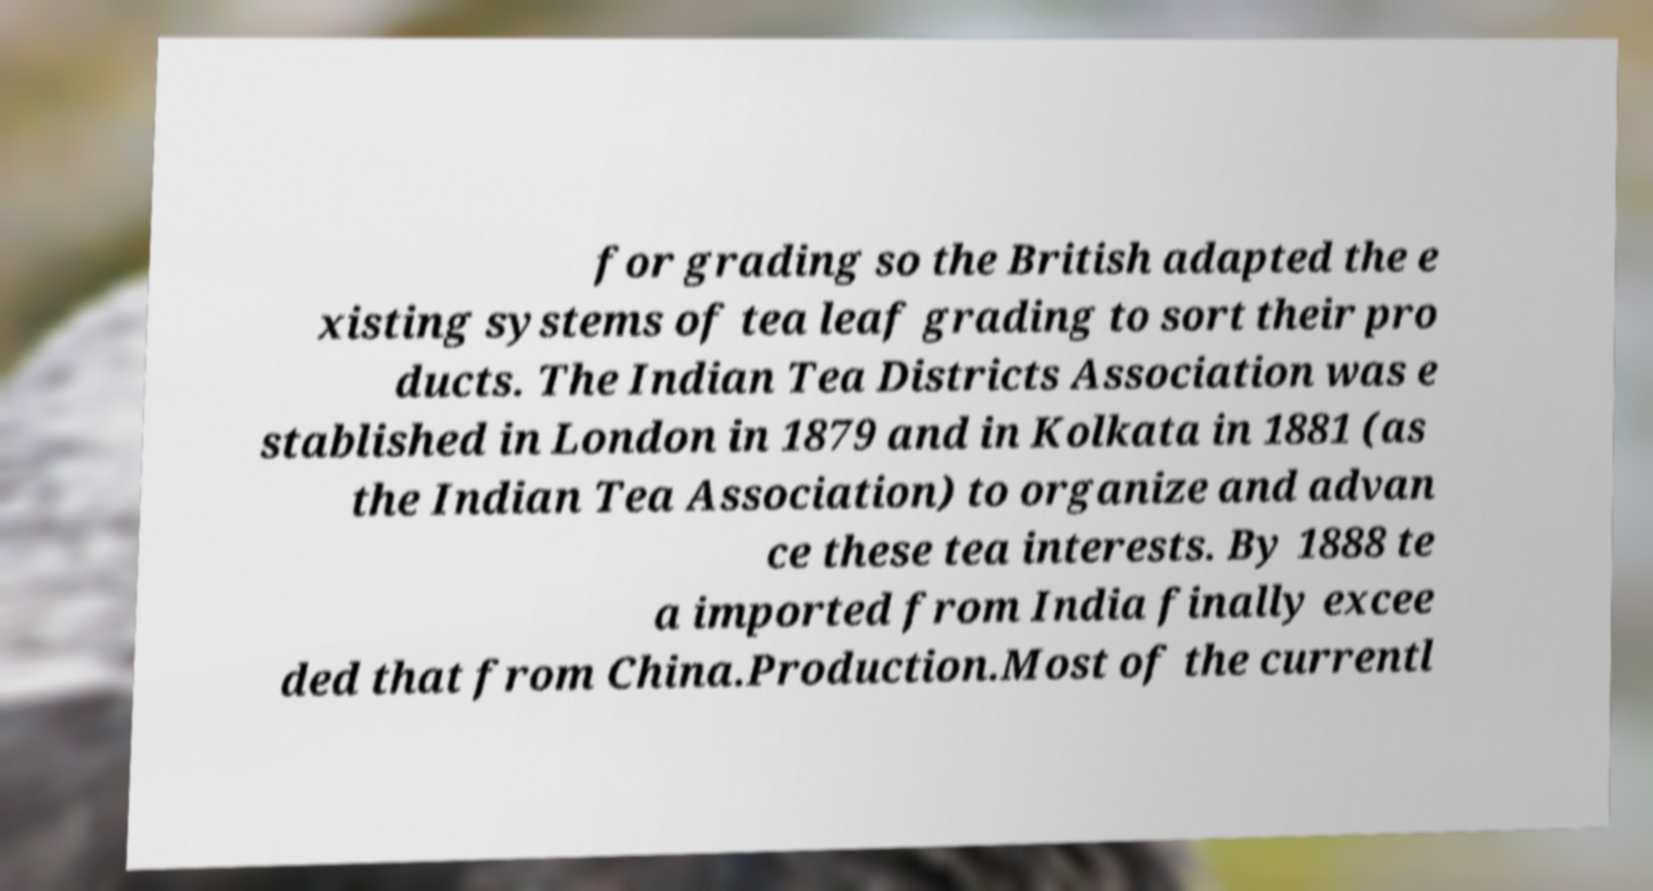For documentation purposes, I need the text within this image transcribed. Could you provide that? for grading so the British adapted the e xisting systems of tea leaf grading to sort their pro ducts. The Indian Tea Districts Association was e stablished in London in 1879 and in Kolkata in 1881 (as the Indian Tea Association) to organize and advan ce these tea interests. By 1888 te a imported from India finally excee ded that from China.Production.Most of the currentl 